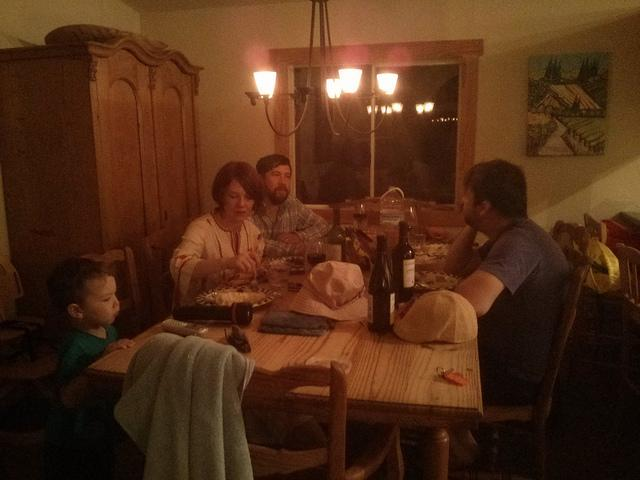Where are these people gathered? Please explain your reasoning. home. They're at home. 